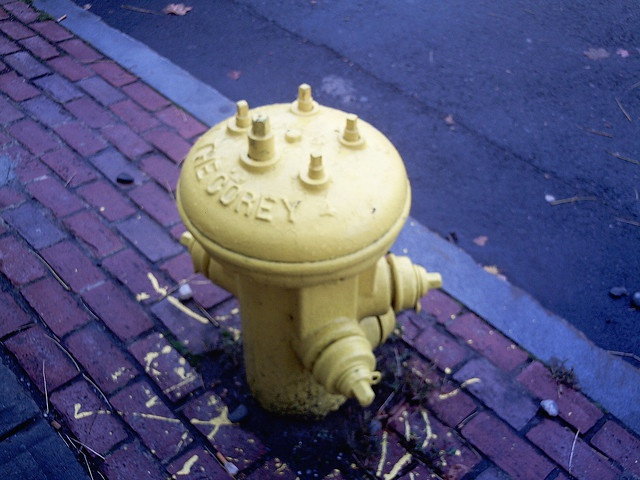Describe the objects in this image and their specific colors. I can see a fire hydrant in purple, tan, beige, khaki, and olive tones in this image. 